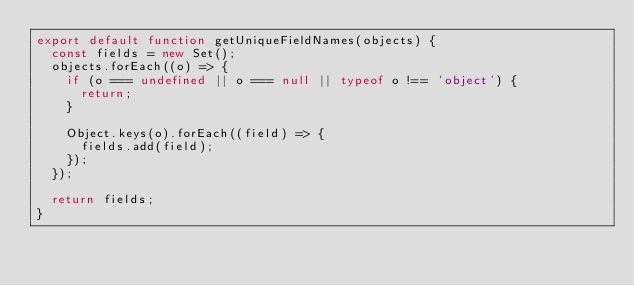Convert code to text. <code><loc_0><loc_0><loc_500><loc_500><_JavaScript_>export default function getUniqueFieldNames(objects) {
  const fields = new Set();
  objects.forEach((o) => {
    if (o === undefined || o === null || typeof o !== 'object') {
      return;
    }

    Object.keys(o).forEach((field) => {
      fields.add(field);
    });
  });

  return fields;
}
</code> 